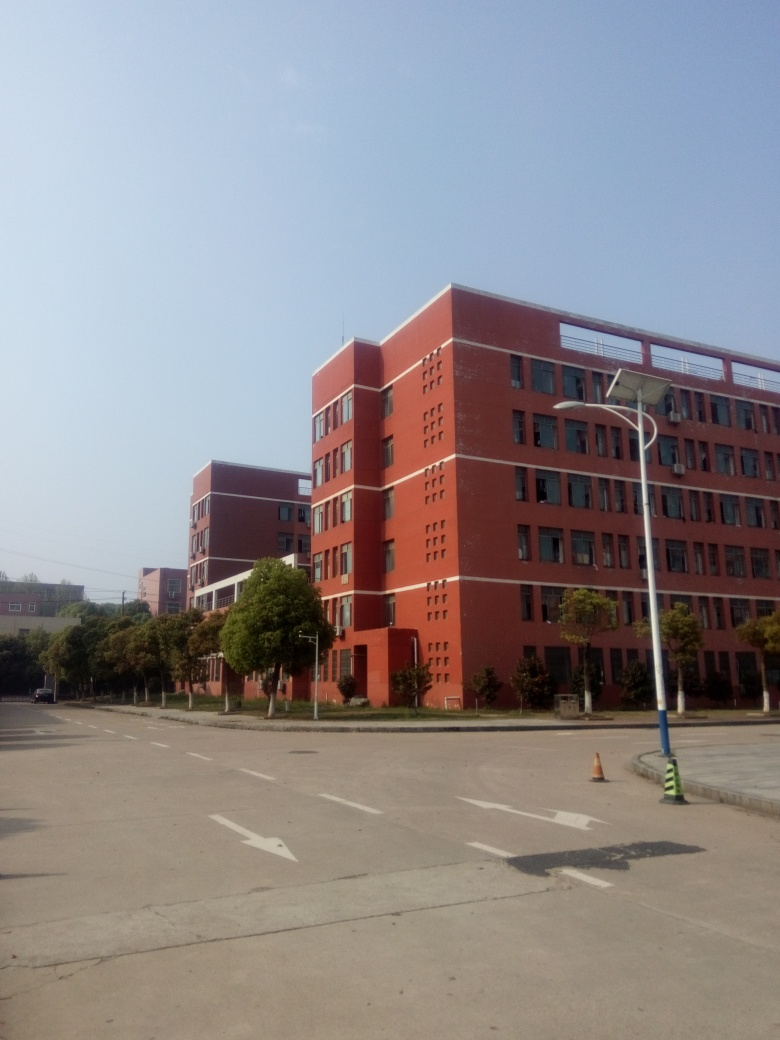Are there any quality issues related to saturation? The image appears well-balanced in terms of saturation, with the colors looking quite natural and true to life. There are no signs of over-saturation where the colors might look excessively bright or under-saturation where the image would appear washed out. 